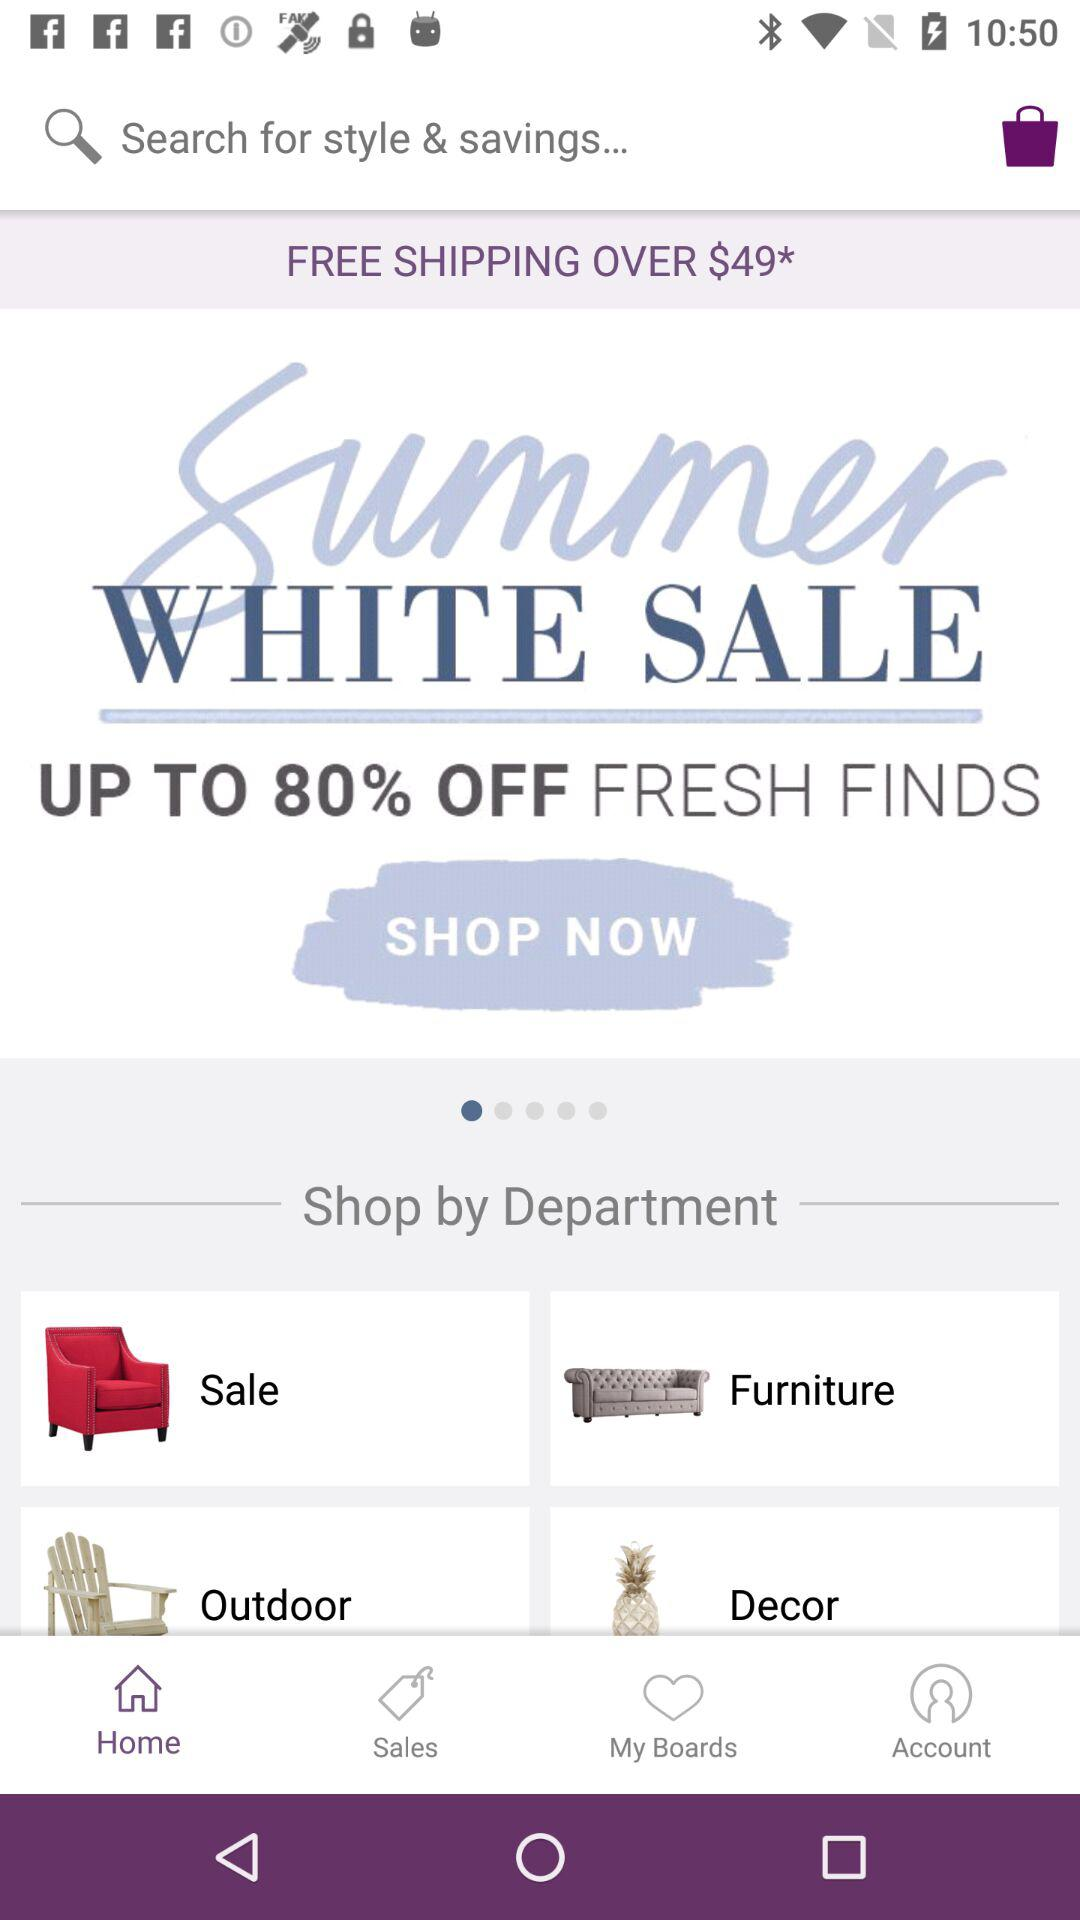How many dollars off is the highest discount?
Answer the question using a single word or phrase. 80% 